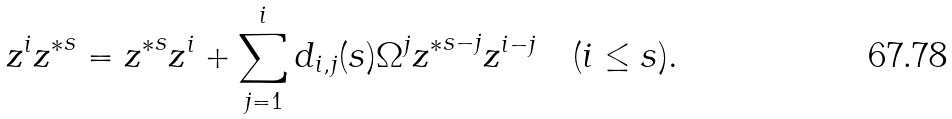<formula> <loc_0><loc_0><loc_500><loc_500>z ^ { i } { z ^ { * } } ^ { s } = { z ^ { * } } ^ { s } z ^ { i } + \sum _ { j = 1 } ^ { i } d _ { i , j } ( s ) \Omega ^ { j } { z ^ { * } } ^ { s - j } z ^ { i - j } \quad ( i \leq s ) .</formula> 